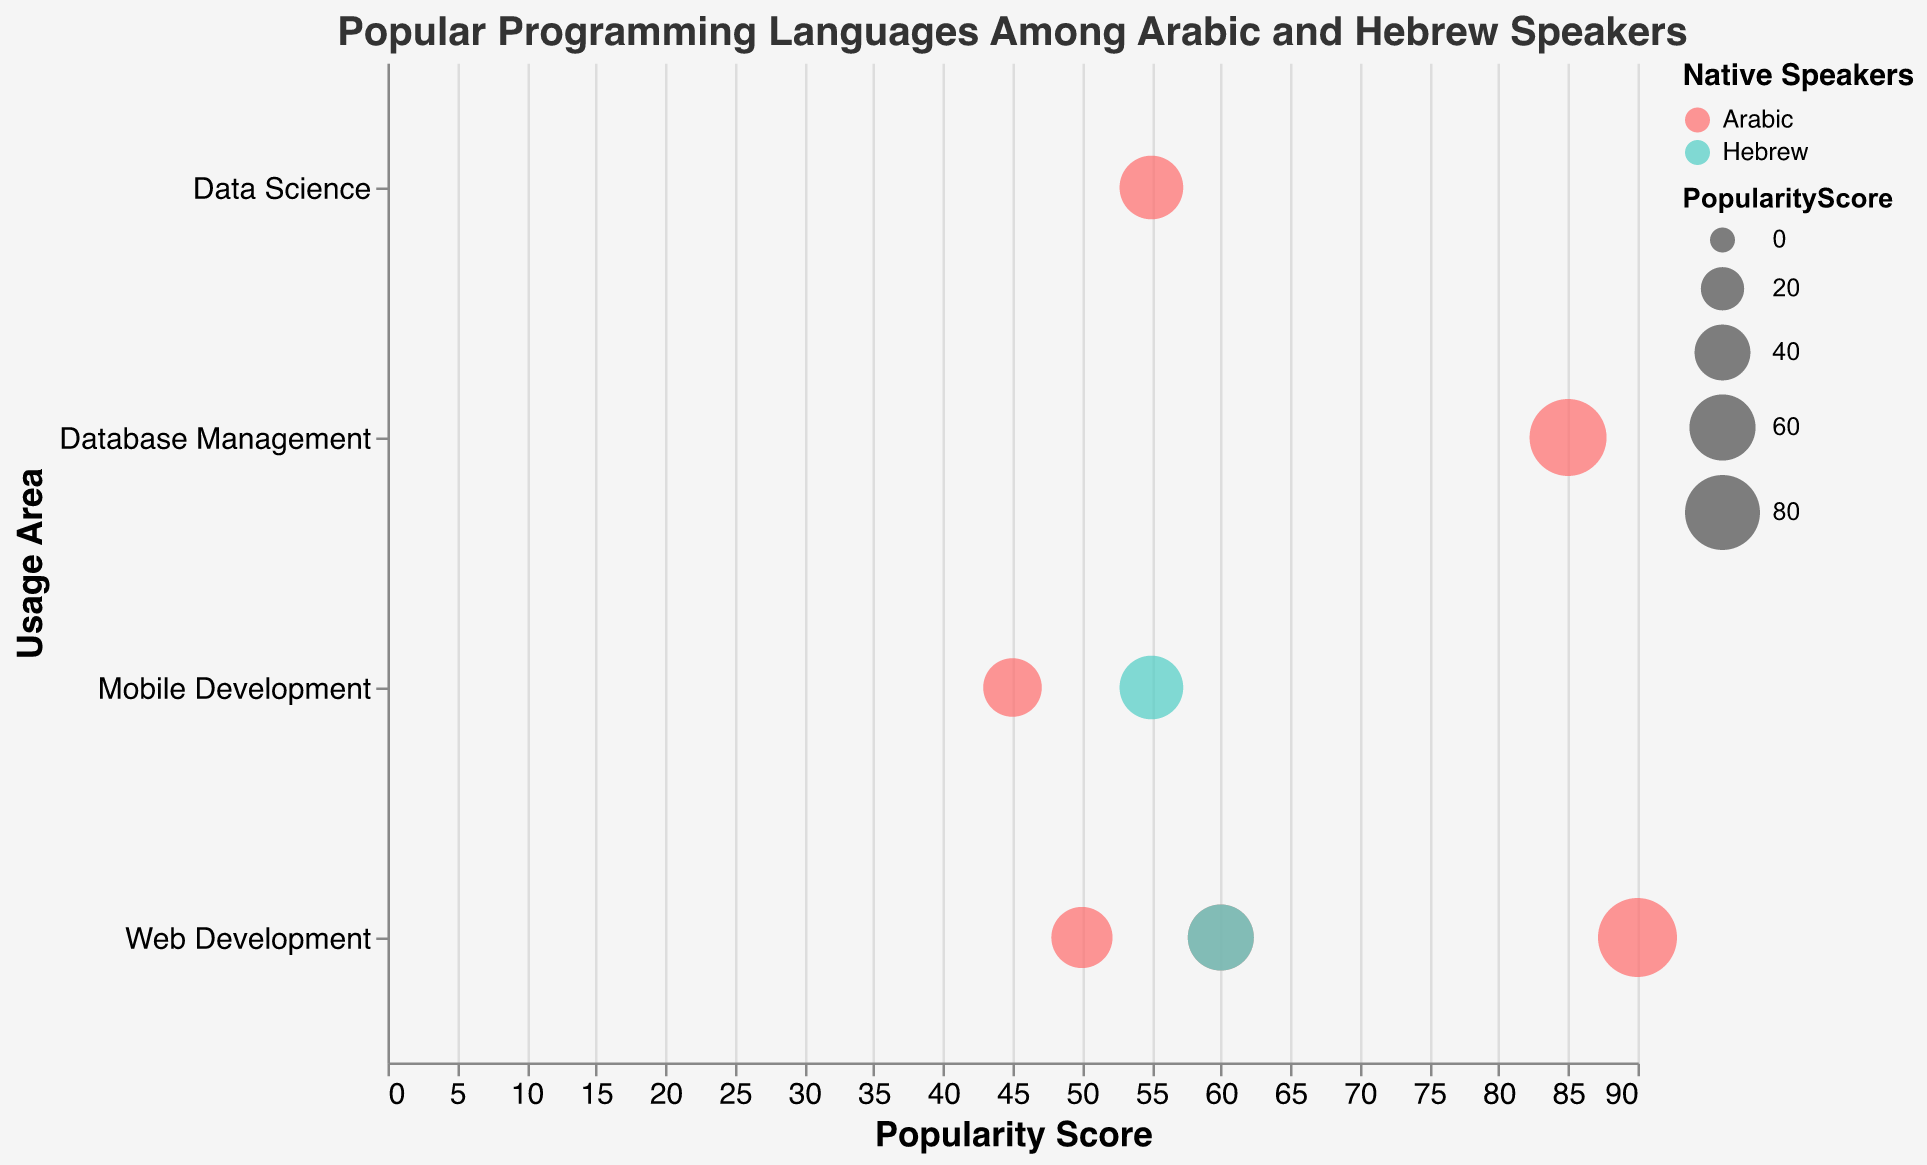Which programming language has the highest popularity score among Arabic speakers? To find the programming language with the highest popularity score among Arabic speakers, observe the x-axis (Popularity Score) and the color for Arabic speakers (#FF6B6B). The bubble farthest right and in red is HTML/CSS with a score of 90.
Answer: HTML/CSS Which two languages are used for Web Development by Arabic speakers? Look for the bubbles colored red (#FF6B6B) located in the Web Development category on the y-axis. The languages are PHP and Ruby.
Answer: PHP and Ruby What is the combined popularity score of all languages used for Mobile Development? Identify bubbles in the Mobile Development category on the y-axis. Sum their Popularity Scores: Swift (55) + Kotlin (45). Combined score is 55 + 45 = 100.
Answer: 100 Which language used for Data Science is among the most popular? Identify the bubble placed in the Data Science category on the y-axis with its popularity score and color. R is the language used for Data Science by Arabic speakers with a popularity score of 55.
Answer: R How does the popularity score of Swift compare to R? Check the popularity score on the x-axis for both Swift and R. Swift has a score of 55, and R has a score of 55 as well. The scores are equal.
Answer: They are equal Which usage area has the highest number of unique programming languages represented? Count the number of unique programming languages (bubbles) in each usage area along the y-axis. Web Development has 4 languages (PHP, Ruby, TypeScript, HTML/CSS).
Answer: Web Development What is the average popularity score of programming languages among Hebrew speakers? Look for bubbles colored in turqoise (#4ECDC4) and average their Popularity Scores: Swift (55) + TypeScript (60). Average score is (55 + 60) / 2 = 57.5.
Answer: 57.5 Which language has the lowest popularity score? Find the bubble placed closest to 0 on the x-axis. Kotlin has the lowest popularity score with 45.
Answer: Kotlin What's the difference in the maximum popularity score between Arabic and Hebrew speakers? Identify the maximum popularity scores for both groups: Arabic (HTML/CSS with 90), Hebrew (TypeScript with 60). Difference is 90 - 60 = 30.
Answer: 30 